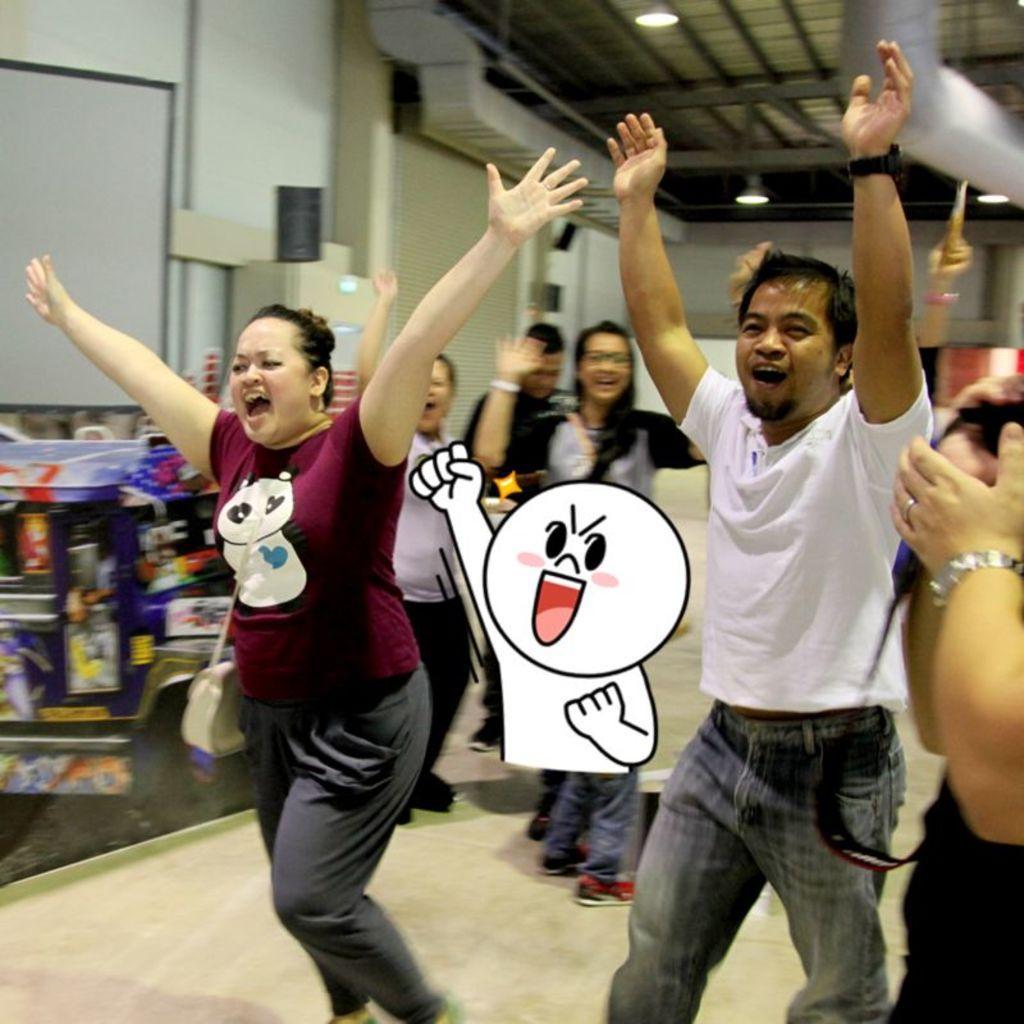How would you summarize this image in a sentence or two? In this picture we can see some men and women in the hall and raising their hand up. Behind we can see white walls, ducts and spot lights on the ceiling. 